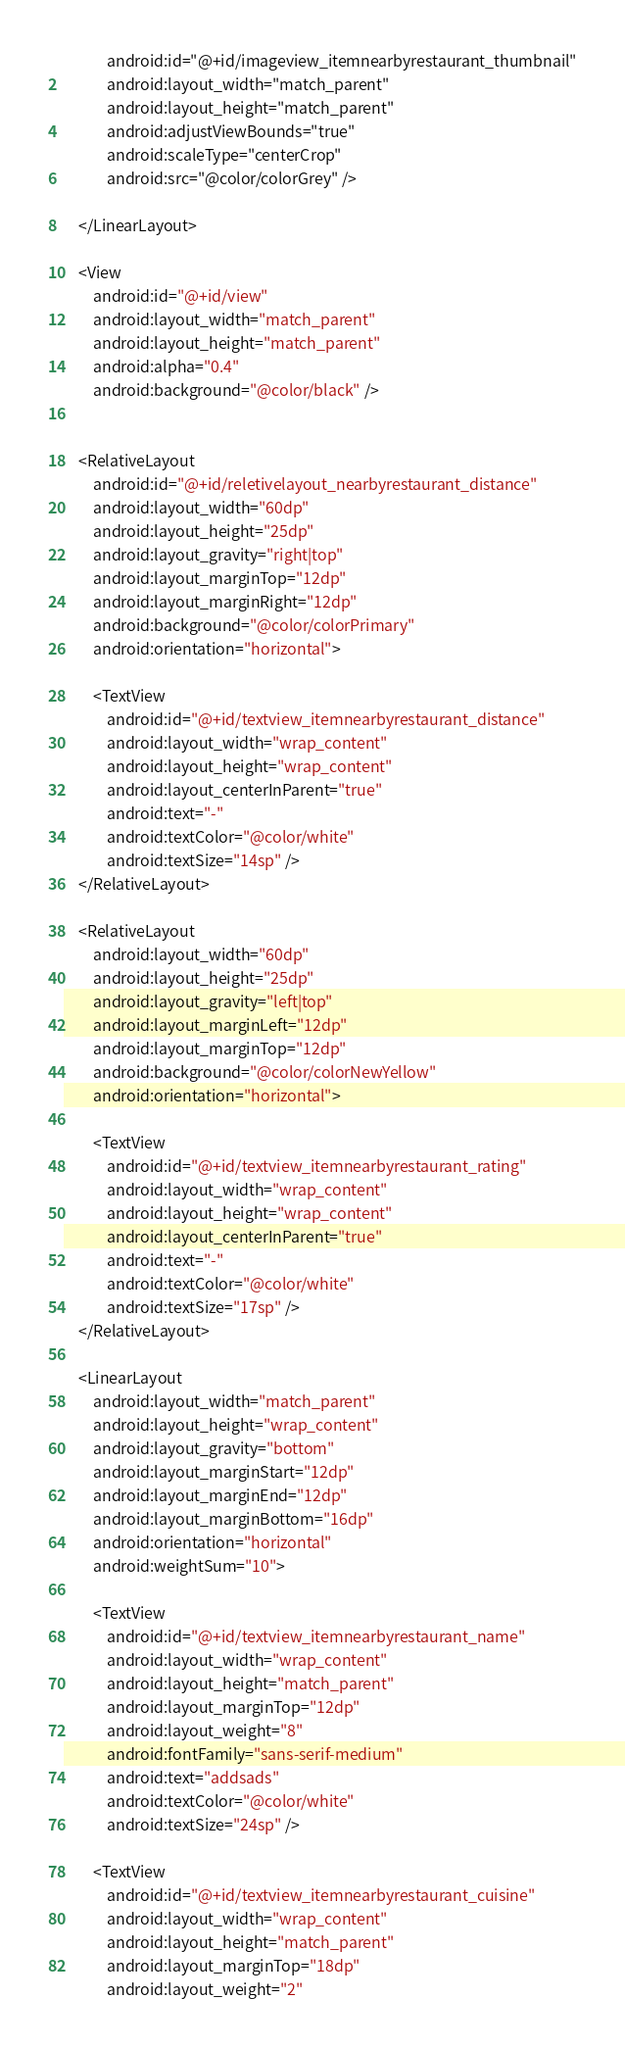<code> <loc_0><loc_0><loc_500><loc_500><_XML_>            android:id="@+id/imageview_itemnearbyrestaurant_thumbnail"
            android:layout_width="match_parent"
            android:layout_height="match_parent"
            android:adjustViewBounds="true"
            android:scaleType="centerCrop"
            android:src="@color/colorGrey" />

    </LinearLayout>

    <View
        android:id="@+id/view"
        android:layout_width="match_parent"
        android:layout_height="match_parent"
        android:alpha="0.4"
        android:background="@color/black" />


    <RelativeLayout
        android:id="@+id/reletivelayout_nearbyrestaurant_distance"
        android:layout_width="60dp"
        android:layout_height="25dp"
        android:layout_gravity="right|top"
        android:layout_marginTop="12dp"
        android:layout_marginRight="12dp"
        android:background="@color/colorPrimary"
        android:orientation="horizontal">

        <TextView
            android:id="@+id/textview_itemnearbyrestaurant_distance"
            android:layout_width="wrap_content"
            android:layout_height="wrap_content"
            android:layout_centerInParent="true"
            android:text="-"
            android:textColor="@color/white"
            android:textSize="14sp" />
    </RelativeLayout>

    <RelativeLayout
        android:layout_width="60dp"
        android:layout_height="25dp"
        android:layout_gravity="left|top"
        android:layout_marginLeft="12dp"
        android:layout_marginTop="12dp"
        android:background="@color/colorNewYellow"
        android:orientation="horizontal">

        <TextView
            android:id="@+id/textview_itemnearbyrestaurant_rating"
            android:layout_width="wrap_content"
            android:layout_height="wrap_content"
            android:layout_centerInParent="true"
            android:text="-"
            android:textColor="@color/white"
            android:textSize="17sp" />
    </RelativeLayout>

    <LinearLayout
        android:layout_width="match_parent"
        android:layout_height="wrap_content"
        android:layout_gravity="bottom"
        android:layout_marginStart="12dp"
        android:layout_marginEnd="12dp"
        android:layout_marginBottom="16dp"
        android:orientation="horizontal"
        android:weightSum="10">

        <TextView
            android:id="@+id/textview_itemnearbyrestaurant_name"
            android:layout_width="wrap_content"
            android:layout_height="match_parent"
            android:layout_marginTop="12dp"
            android:layout_weight="8"
            android:fontFamily="sans-serif-medium"
            android:text="addsads"
            android:textColor="@color/white"
            android:textSize="24sp" />

        <TextView
            android:id="@+id/textview_itemnearbyrestaurant_cuisine"
            android:layout_width="wrap_content"
            android:layout_height="match_parent"
            android:layout_marginTop="18dp"
            android:layout_weight="2"</code> 